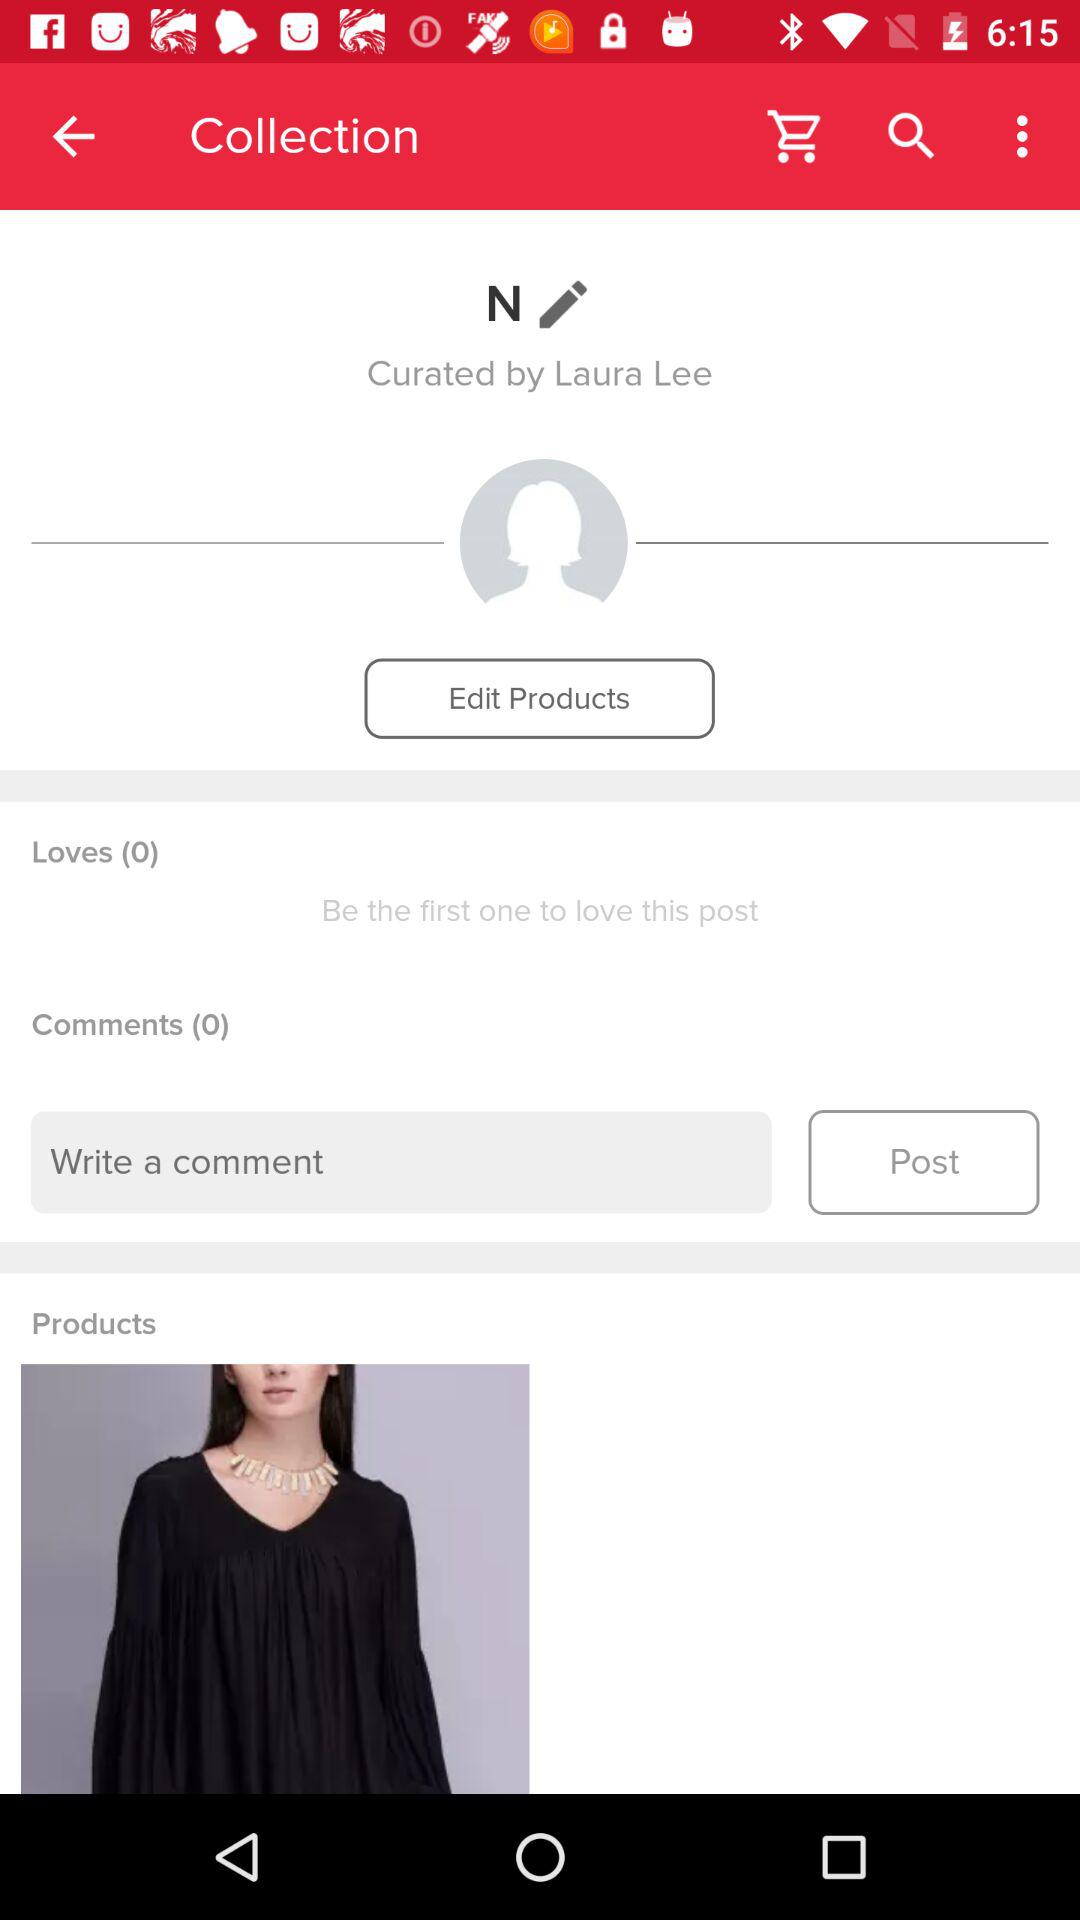How many more comments than loves does the post have?
Answer the question using a single word or phrase. 0 